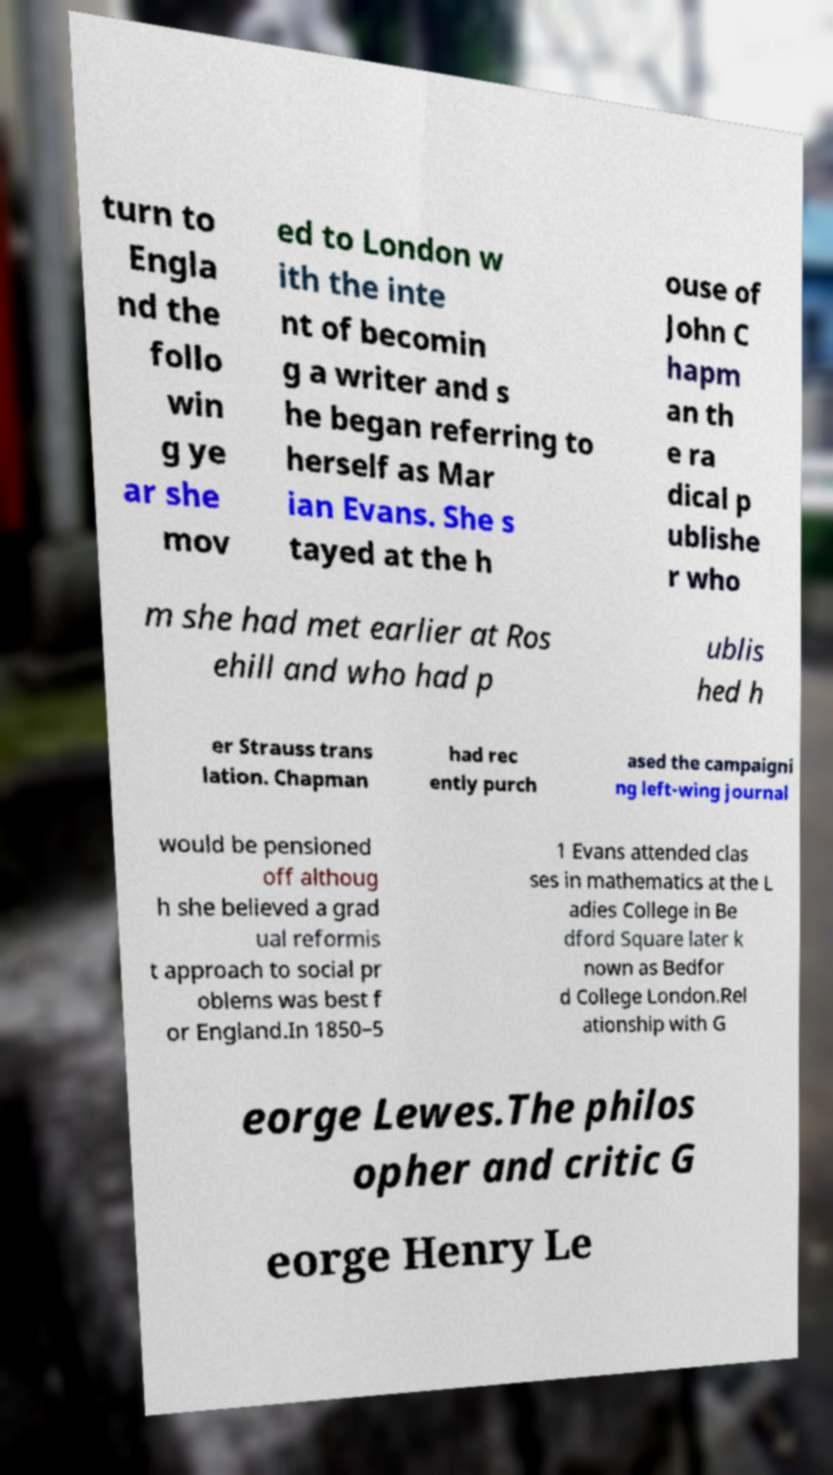Can you read and provide the text displayed in the image?This photo seems to have some interesting text. Can you extract and type it out for me? turn to Engla nd the follo win g ye ar she mov ed to London w ith the inte nt of becomin g a writer and s he began referring to herself as Mar ian Evans. She s tayed at the h ouse of John C hapm an th e ra dical p ublishe r who m she had met earlier at Ros ehill and who had p ublis hed h er Strauss trans lation. Chapman had rec ently purch ased the campaigni ng left-wing journal would be pensioned off althoug h she believed a grad ual reformis t approach to social pr oblems was best f or England.In 1850–5 1 Evans attended clas ses in mathematics at the L adies College in Be dford Square later k nown as Bedfor d College London.Rel ationship with G eorge Lewes.The philos opher and critic G eorge Henry Le 